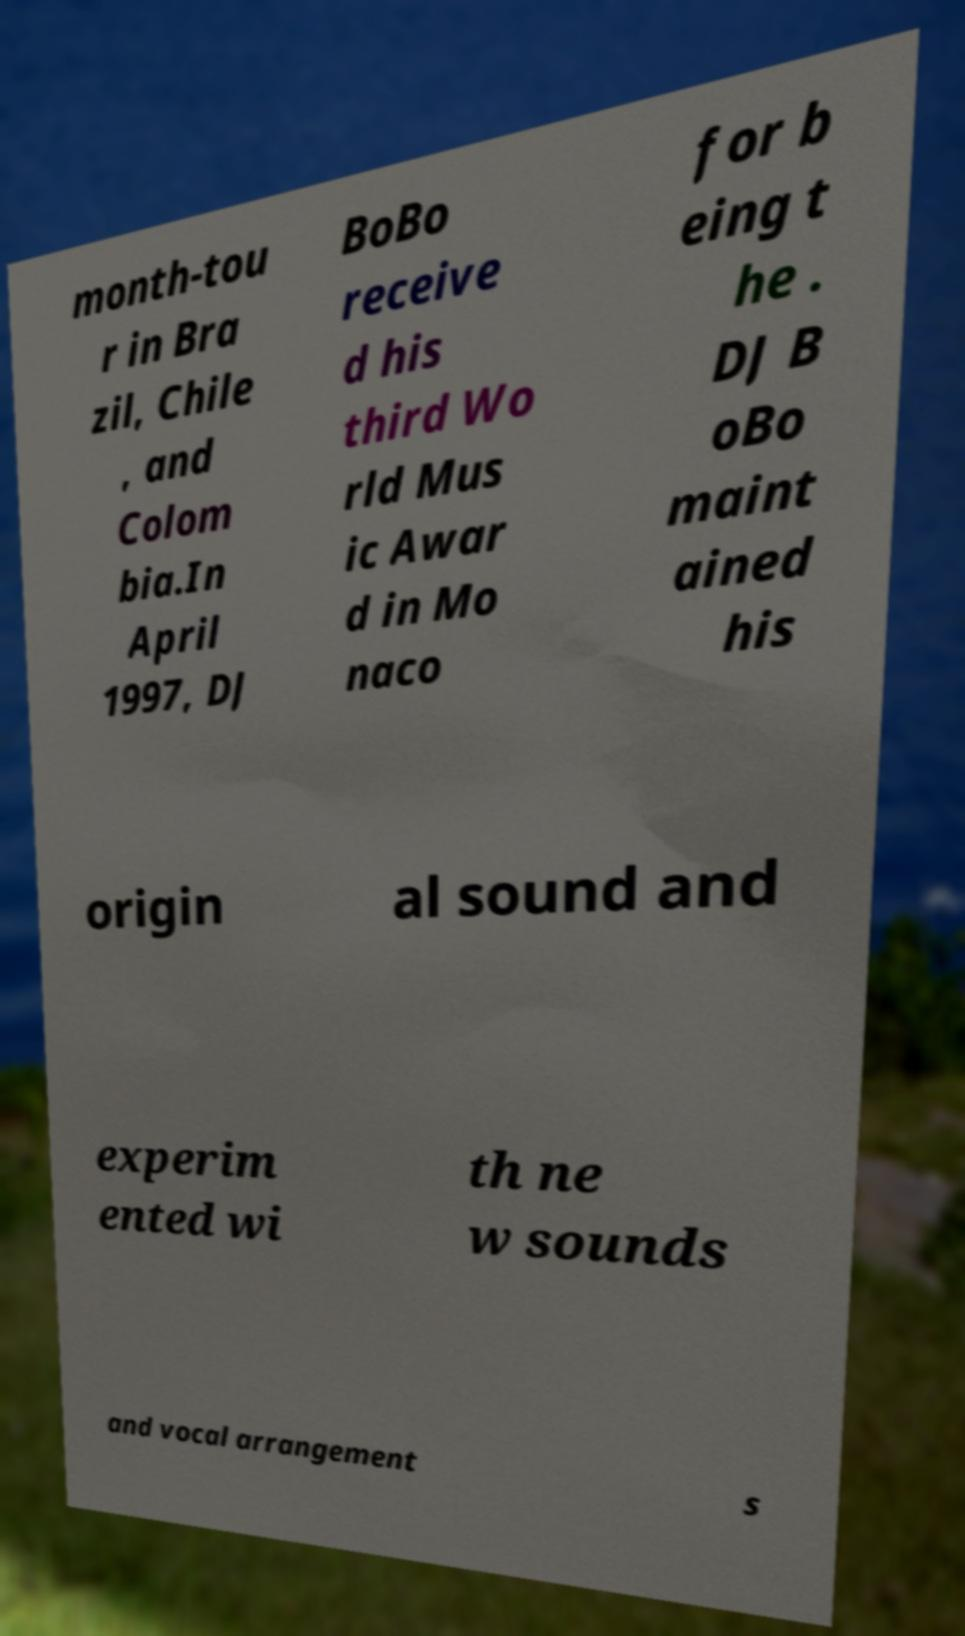Can you read and provide the text displayed in the image?This photo seems to have some interesting text. Can you extract and type it out for me? month-tou r in Bra zil, Chile , and Colom bia.In April 1997, DJ BoBo receive d his third Wo rld Mus ic Awar d in Mo naco for b eing t he . DJ B oBo maint ained his origin al sound and experim ented wi th ne w sounds and vocal arrangement s 